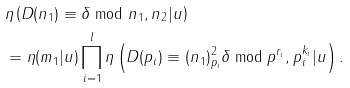Convert formula to latex. <formula><loc_0><loc_0><loc_500><loc_500>& \eta \left ( D ( n _ { 1 } ) \equiv \delta \bmod { n _ { 1 } } , n _ { 2 } | u \right ) \\ & = \eta ( m _ { 1 } | u ) \prod _ { i = 1 } ^ { l } \eta \left ( D ( p _ { i } ) \equiv ( n _ { 1 } ) _ { p _ { i } } ^ { 2 } \delta \bmod { p ^ { r _ { i } } } , p _ { i } ^ { k _ { i } } | u \right ) .</formula> 